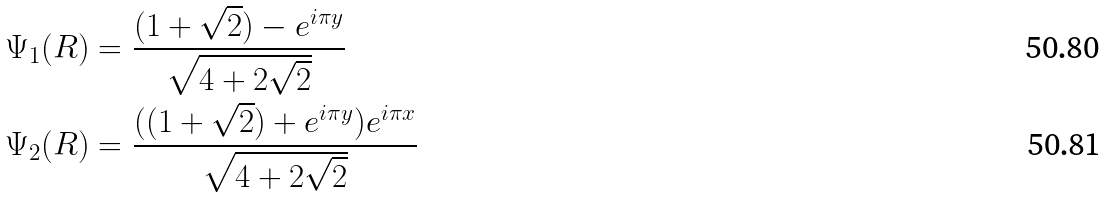<formula> <loc_0><loc_0><loc_500><loc_500>\Psi _ { 1 } ( R ) & = \frac { ( 1 + \sqrt { 2 } ) - e ^ { i \pi y } } { \sqrt { 4 + 2 \sqrt { 2 } } } \\ \Psi _ { 2 } ( R ) & = \frac { ( ( 1 + \sqrt { 2 } ) + e ^ { i \pi y } ) e ^ { i \pi x } } { \sqrt { 4 + 2 \sqrt { 2 } } }</formula> 